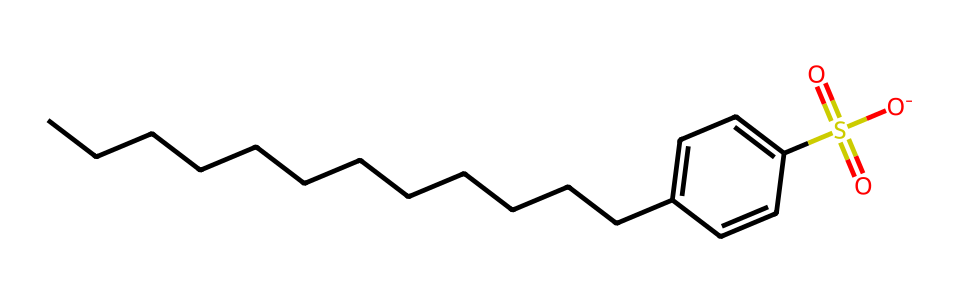How many carbon atoms are in this compound? Count the number of 'C' symbols in the SMILES representation. There are 14 'C' symbols indicating 14 carbon atoms in the compound.
Answer: 14 What functional group is represented in this chemical? The SMILES shows a 'S(=O)(=O)' notation, which indicates a sulfonate functional group (R-SO3). Here, the 'S' corresponds to sulfur and it is bonded to three oxygen atoms, two of which are double-bonded.
Answer: sulfonate What type of surfactant does this compound represent? This compound includes an alkyl chain and a sulfonate group, which characterizes it as an anionic surfactant commonly used in detergents. The alkylbenzene structure provides hydrophobic properties while the sulfonate imparts hydrophilic properties.
Answer: anionic surfactant How many aromatic rings does this compound contain? The presence of 'C1=CC' indicates the presence of an aromatic ring in the structure. The notation 'C1' indicates the start of a cyclic structure, confirming there is one aromatic ring.
Answer: 1 What is the total number of oxygen atoms in this compound? In the SMILES notation, there are three 'O' symbols that signify the presence of three oxygen atoms. One oxygen is part of the sulfonate group, while the other two are bonded to sulfur.
Answer: 3 What is the role of the sulfonate group in cleaning effectiveness? The sulfonate group serves to enhance the solubility of the compound in water and creates a hydrophilic area that allows it to interact with water, effectively lowering the surface tension and aiding in the removal of dirt and oils.
Answer: enhance solubility 